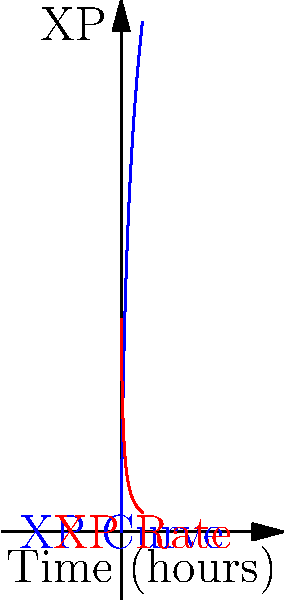In your indie game, player experience points (XP) are modeled by the function $XP(t) = 100 \ln(t+1)$, where $t$ is the time in hours. At what point in time is the rate of XP gain equal to 25 XP per hour? To solve this problem, we need to follow these steps:

1) First, we need to find the rate of XP gain. This is given by the derivative of the XP function:

   $\frac{d}{dt}XP(t) = \frac{100}{t+1}$

2) We want to find when this rate equals 25 XP per hour:

   $\frac{100}{t+1} = 25$

3) Now we can solve this equation for $t$:

   $100 = 25(t+1)$
   $100 = 25t + 25$
   $75 = 25t$
   $t = 3$

4) To verify, we can plug this back into our rate function:

   $\frac{100}{3+1} = \frac{100}{4} = 25$

Therefore, the rate of XP gain is 25 XP per hour when $t = 3$ hours.

This problem demonstrates how to use calculus to analyze game mechanics, specifically the rate of change in player experience over time. It's relevant to balancing player progression in your indie game development.
Answer: 3 hours 